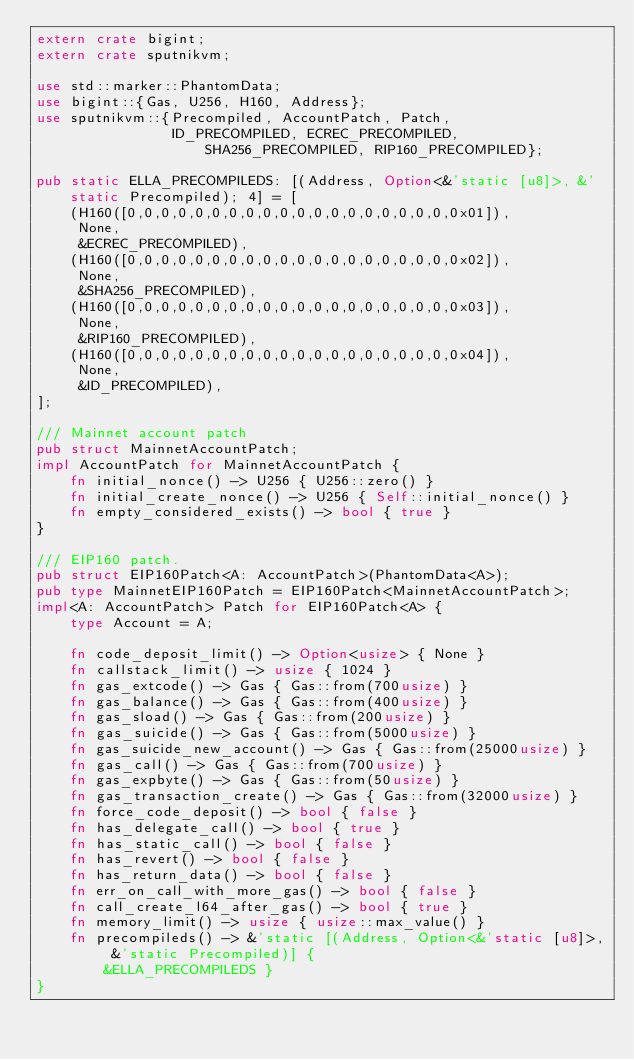<code> <loc_0><loc_0><loc_500><loc_500><_Rust_>extern crate bigint;
extern crate sputnikvm;

use std::marker::PhantomData;
use bigint::{Gas, U256, H160, Address};
use sputnikvm::{Precompiled, AccountPatch, Patch,
                ID_PRECOMPILED, ECREC_PRECOMPILED, SHA256_PRECOMPILED, RIP160_PRECOMPILED};

pub static ELLA_PRECOMPILEDS: [(Address, Option<&'static [u8]>, &'static Precompiled); 4] = [
    (H160([0,0,0,0,0,0,0,0,0,0,0,0,0,0,0,0,0,0,0,0x01]),
     None,
     &ECREC_PRECOMPILED),
    (H160([0,0,0,0,0,0,0,0,0,0,0,0,0,0,0,0,0,0,0,0x02]),
     None,
     &SHA256_PRECOMPILED),
    (H160([0,0,0,0,0,0,0,0,0,0,0,0,0,0,0,0,0,0,0,0x03]),
     None,
     &RIP160_PRECOMPILED),
    (H160([0,0,0,0,0,0,0,0,0,0,0,0,0,0,0,0,0,0,0,0x04]),
     None,
     &ID_PRECOMPILED),
];

/// Mainnet account patch
pub struct MainnetAccountPatch;
impl AccountPatch for MainnetAccountPatch {
    fn initial_nonce() -> U256 { U256::zero() }
    fn initial_create_nonce() -> U256 { Self::initial_nonce() }
    fn empty_considered_exists() -> bool { true }
}

/// EIP160 patch.
pub struct EIP160Patch<A: AccountPatch>(PhantomData<A>);
pub type MainnetEIP160Patch = EIP160Patch<MainnetAccountPatch>;
impl<A: AccountPatch> Patch for EIP160Patch<A> {
    type Account = A;

    fn code_deposit_limit() -> Option<usize> { None }
    fn callstack_limit() -> usize { 1024 }
    fn gas_extcode() -> Gas { Gas::from(700usize) }
    fn gas_balance() -> Gas { Gas::from(400usize) }
    fn gas_sload() -> Gas { Gas::from(200usize) }
    fn gas_suicide() -> Gas { Gas::from(5000usize) }
    fn gas_suicide_new_account() -> Gas { Gas::from(25000usize) }
    fn gas_call() -> Gas { Gas::from(700usize) }
    fn gas_expbyte() -> Gas { Gas::from(50usize) }
    fn gas_transaction_create() -> Gas { Gas::from(32000usize) }
    fn force_code_deposit() -> bool { false }
    fn has_delegate_call() -> bool { true }
    fn has_static_call() -> bool { false }
    fn has_revert() -> bool { false }
    fn has_return_data() -> bool { false }
    fn err_on_call_with_more_gas() -> bool { false }
    fn call_create_l64_after_gas() -> bool { true }
    fn memory_limit() -> usize { usize::max_value() }
    fn precompileds() -> &'static [(Address, Option<&'static [u8]>, &'static Precompiled)] {
        &ELLA_PRECOMPILEDS }
}
</code> 